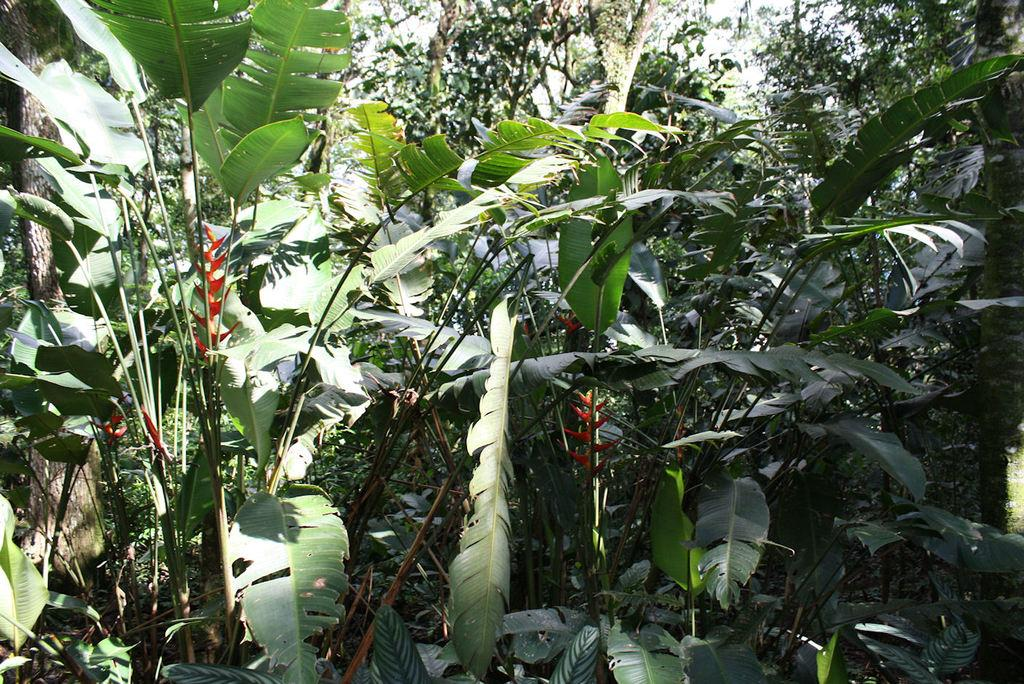What type of vegetation is visible in the image? There are trees in the image. What is visible at the top of the image? The sky is visible at the top of the image. How many bricks can be seen stacked together in the image? There are no bricks present in the image; it features trees and the sky. Are there any snails visible on the trees in the image? There are no snails visible on the trees in the image. 